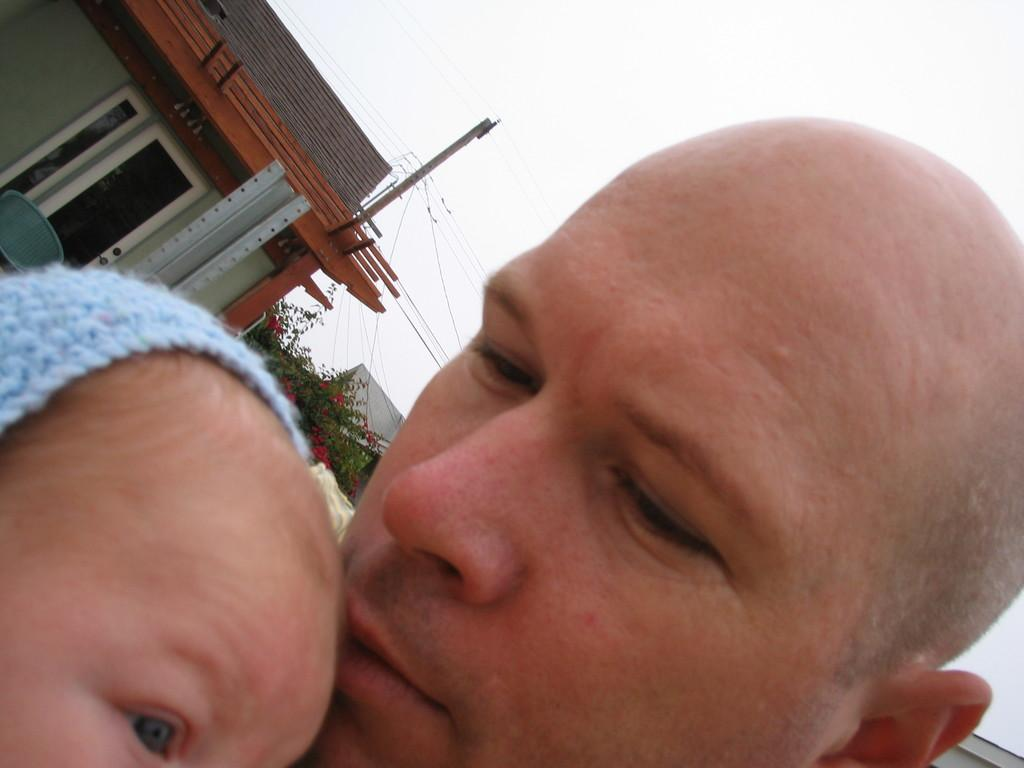How many people's faces can be seen in the image? There are two people's faces in the image. What can be seen in the background of the image? Buildings, a door, a current pole, wires, and trees can be seen in the background. What is the color of the sky in the image? The sky appears to be white in color. What type of instrument is being played by the person in the image? There is no person playing an instrument in the image. What is the weather like in the image? The weather cannot be determined from the image, as only the color of the sky is mentioned, not any weather conditions. 